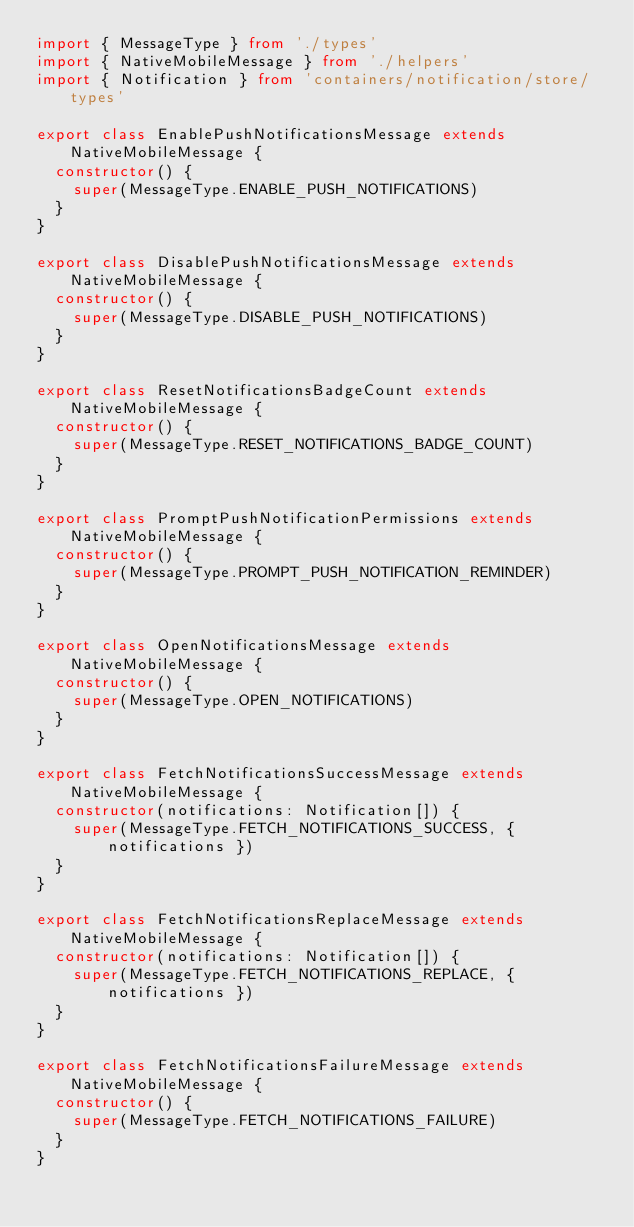<code> <loc_0><loc_0><loc_500><loc_500><_TypeScript_>import { MessageType } from './types'
import { NativeMobileMessage } from './helpers'
import { Notification } from 'containers/notification/store/types'

export class EnablePushNotificationsMessage extends NativeMobileMessage {
  constructor() {
    super(MessageType.ENABLE_PUSH_NOTIFICATIONS)
  }
}

export class DisablePushNotificationsMessage extends NativeMobileMessage {
  constructor() {
    super(MessageType.DISABLE_PUSH_NOTIFICATIONS)
  }
}

export class ResetNotificationsBadgeCount extends NativeMobileMessage {
  constructor() {
    super(MessageType.RESET_NOTIFICATIONS_BADGE_COUNT)
  }
}

export class PromptPushNotificationPermissions extends NativeMobileMessage {
  constructor() {
    super(MessageType.PROMPT_PUSH_NOTIFICATION_REMINDER)
  }
}

export class OpenNotificationsMessage extends NativeMobileMessage {
  constructor() {
    super(MessageType.OPEN_NOTIFICATIONS)
  }
}

export class FetchNotificationsSuccessMessage extends NativeMobileMessage {
  constructor(notifications: Notification[]) {
    super(MessageType.FETCH_NOTIFICATIONS_SUCCESS, { notifications })
  }
}

export class FetchNotificationsReplaceMessage extends NativeMobileMessage {
  constructor(notifications: Notification[]) {
    super(MessageType.FETCH_NOTIFICATIONS_REPLACE, { notifications })
  }
}

export class FetchNotificationsFailureMessage extends NativeMobileMessage {
  constructor() {
    super(MessageType.FETCH_NOTIFICATIONS_FAILURE)
  }
}
</code> 